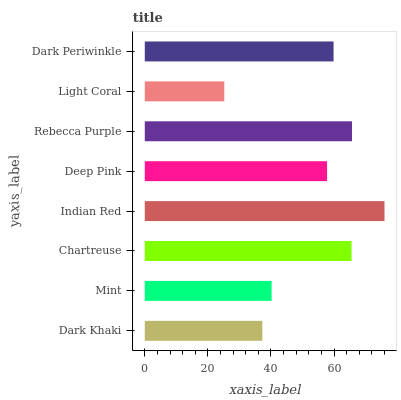Is Light Coral the minimum?
Answer yes or no. Yes. Is Indian Red the maximum?
Answer yes or no. Yes. Is Mint the minimum?
Answer yes or no. No. Is Mint the maximum?
Answer yes or no. No. Is Mint greater than Dark Khaki?
Answer yes or no. Yes. Is Dark Khaki less than Mint?
Answer yes or no. Yes. Is Dark Khaki greater than Mint?
Answer yes or no. No. Is Mint less than Dark Khaki?
Answer yes or no. No. Is Dark Periwinkle the high median?
Answer yes or no. Yes. Is Deep Pink the low median?
Answer yes or no. Yes. Is Light Coral the high median?
Answer yes or no. No. Is Dark Periwinkle the low median?
Answer yes or no. No. 